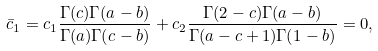<formula> <loc_0><loc_0><loc_500><loc_500>\bar { c } _ { 1 } = c _ { 1 } \frac { \Gamma ( c ) \Gamma ( a - b ) } { \Gamma ( a ) \Gamma ( c - b ) } + c _ { 2 } \frac { \Gamma ( 2 - c ) \Gamma ( a - b ) } { \Gamma ( a - c + 1 ) \Gamma ( 1 - b ) } = 0 ,</formula> 